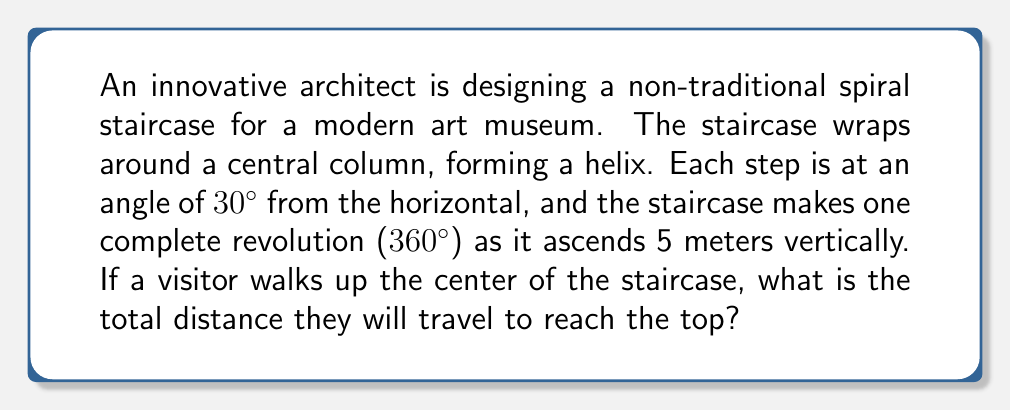Can you solve this math problem? Let's approach this step-by-step:

1) First, we need to visualize the problem. The helix can be "unwrapped" into a right triangle:
   - The base of the triangle is the circumference of one revolution
   - The height of the triangle is the vertical rise (5 meters)
   - The hypotenuse is the path traveled

2) We know the angle of inclination is 30°. This forms a 30-60-90 triangle with the horizontal plane.

3) In a 30-60-90 triangle, if we denote the shortest side as x:
   - The hypotenuse is 2x
   - The side opposite to the 30° angle is x
   - The side opposite to the 60° angle is x√3

4) In our case, the vertical rise (5 m) corresponds to the x√3 side. So:

   $$5 = x\sqrt{3}$$
   $$x = \frac{5}{\sqrt{3}} \approx 2.89 \text{ m}$$

5) The circumference (base of our triangle) is therefore:

   $$2x = 2 \cdot \frac{5}{\sqrt{3}} \approx 5.77 \text{ m}$$

6) Now we can find the hypotenuse (path traveled) using the Pythagorean theorem:

   $$\text{path}^2 = 5^2 + (2x)^2$$
   $$\text{path}^2 = 25 + (\frac{10}{\sqrt{3}})^2$$
   $$\text{path}^2 = 25 + \frac{100}{3} \approx 58.33$$
   $$\text{path} = \sqrt{25 + \frac{100}{3}} \approx 7.64 \text{ m}$$

Therefore, the visitor will travel approximately 7.64 meters to reach the top of the staircase.
Answer: $\sqrt{25 + \frac{100}{3}} \approx 7.64 \text{ m}$ 